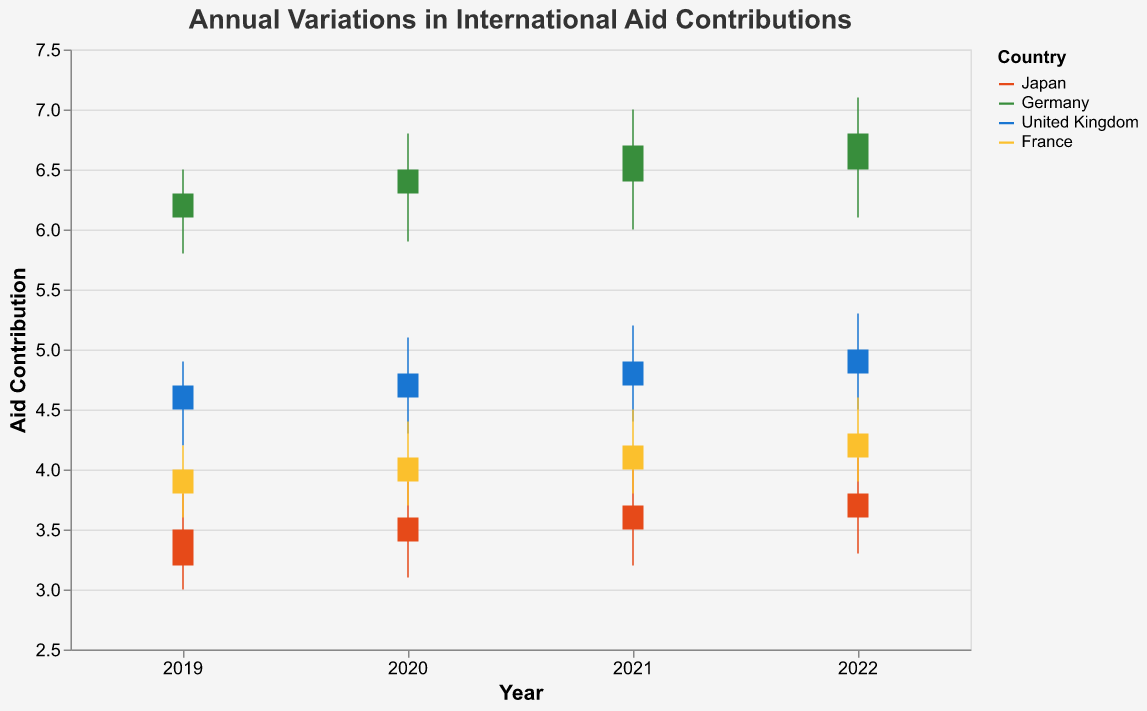What is the title of the chart? The title of the chart is shown at the top of the figure. Read the text inside the title area.
Answer: Annual Variations in International Aid Contributions Which country had the highest aid contribution in 2022? To find this, compare the closing values for each country in 2022. The highest closing value indicates the highest contribution. In 2022, Germany has a closing value of 6.8, which is the highest.
Answer: Germany Between 2019 and 2022, which country's aid contributions consistently increased every year? Observe the closing values for each country over the years from 2019 to 2022. Check if there is a consistent increase each year. Germany shows an increase in the closing values each year from 6.3 (2019) to 6.8 (2022).
Answer: Germany What is the average high value of France's aid contribution over the four years? Add the high values of France for each year, then divide by the number of years (4). The high values are 4.2, 4.4, 4.5, and 4.6. Sum is 17.7, and the average is 17.7/4.
Answer: 4.425 How much did Japan's aid contribution change from the opening value in 2019 to the closing value in 2022? Subtract Japan's closing value in 2022 (3.8) from the opening value in 2019 (3.2).
Answer: 0.6 Which year had the widest range in Germany's aid contribution? Calculate the range for Germany's aid contributions each year by subtracting the low value from the high value. Compare these ranges. 2019: 0.7, 2020: 0.9, 2021: 1.0, 2022: 1.0, so 2021 and 2022 both had the widest range.
Answer: 2021 and 2022 Did France's aid contribution open higher or lower than it closed in 2020? Compare France's opening value (3.9) to the closing value (4.1) in 2020. The opening value is lower.
Answer: Lower Which country had the smallest volatility in aid contributions in 2021? Volatility can be measured by the range (high - low). Examine the range for each country in 2021. Japan: 0.8, Germany: 1.0, United Kingdom: 0.8, France: 0.7. France has the smallest range.
Answer: France What is the total increase in the aid contributions for the United Kingdom from 2019 to 2022? Subtract the closing value in 2019 from the closing value in 2022 for the United Kingdom. The values are 5.0 (2022) and 4.7 (2019). The increase is 5.0 - 4.7.
Answer: 0.3 